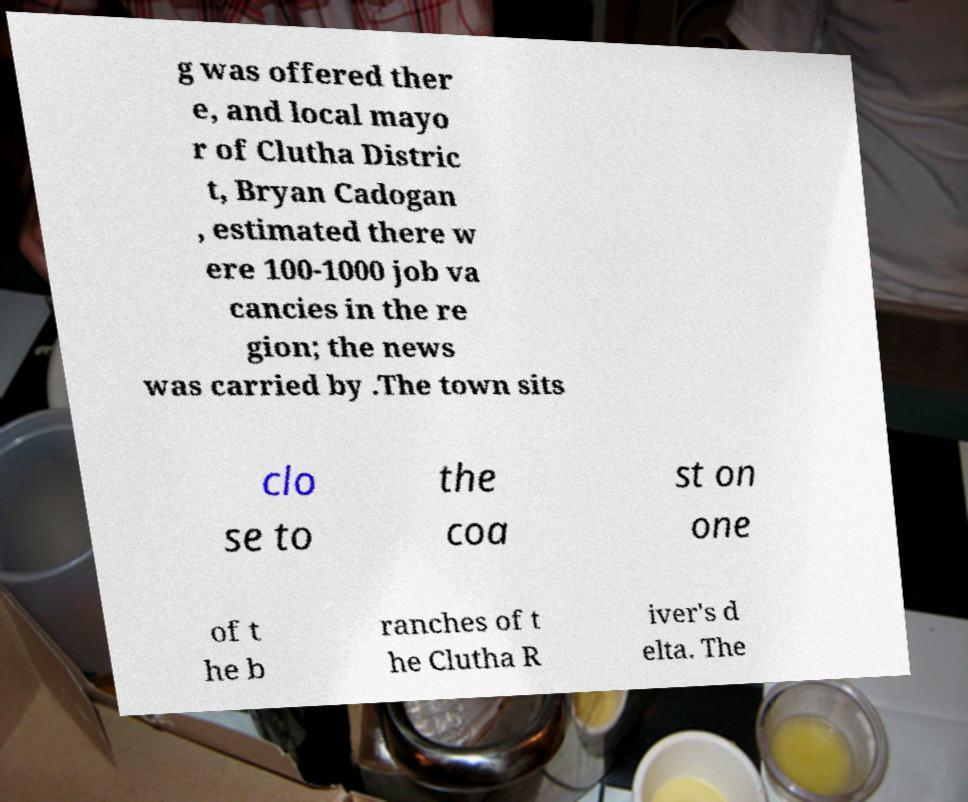There's text embedded in this image that I need extracted. Can you transcribe it verbatim? g was offered ther e, and local mayo r of Clutha Distric t, Bryan Cadogan , estimated there w ere 100-1000 job va cancies in the re gion; the news was carried by .The town sits clo se to the coa st on one of t he b ranches of t he Clutha R iver's d elta. The 